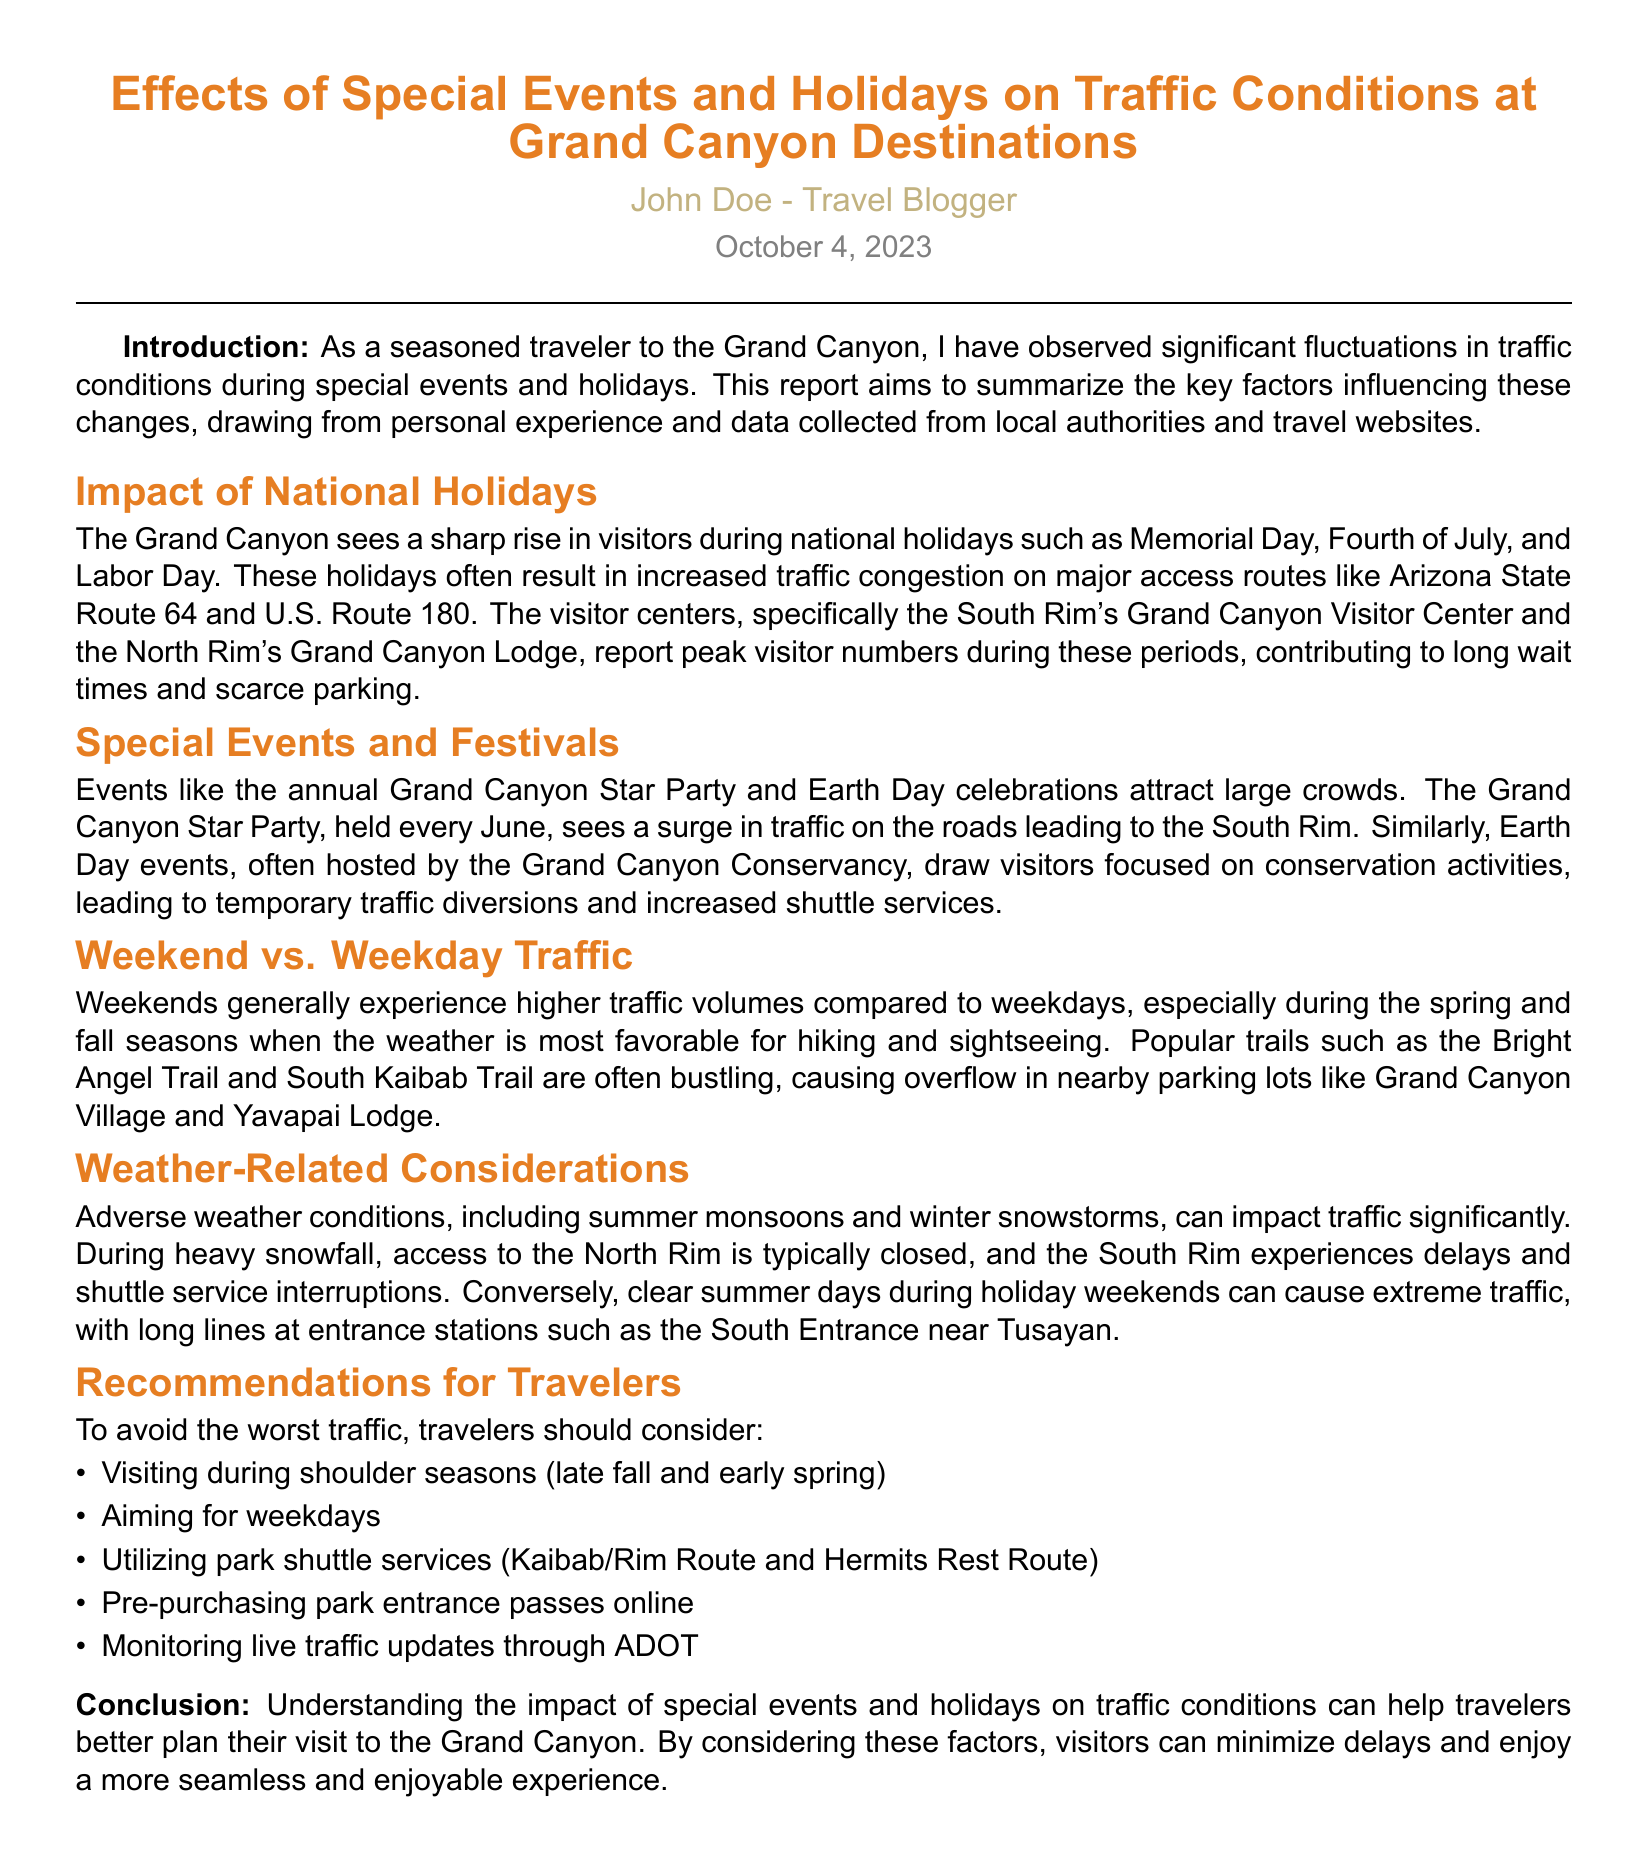What are the peak national holidays for the Grand Canyon? The Grand Canyon sees a sharp rise in visitors during Memorial Day, Fourth of July, and Labor Day.
Answer: Memorial Day, Fourth of July, Labor Day What is the event that occurs every June at the Grand Canyon? The annual Grand Canyon Star Party is held every June, attracting large crowds.
Answer: Grand Canyon Star Party During which seasons is the traffic generally higher on weekends? Weekends generally experience higher traffic volumes during the spring and fall seasons.
Answer: Spring and fall What type of weather can significantly impact traffic at the Grand Canyon? Adverse weather conditions, including summer monsoons and winter snowstorms, can impact traffic significantly.
Answer: Summer monsoons, winter snowstorms What is one recommended strategy to avoid traffic during peak times? Travelers are advised to visit during shoulder seasons (late fall and early spring) to avoid the worst traffic.
Answer: Shoulder seasons 